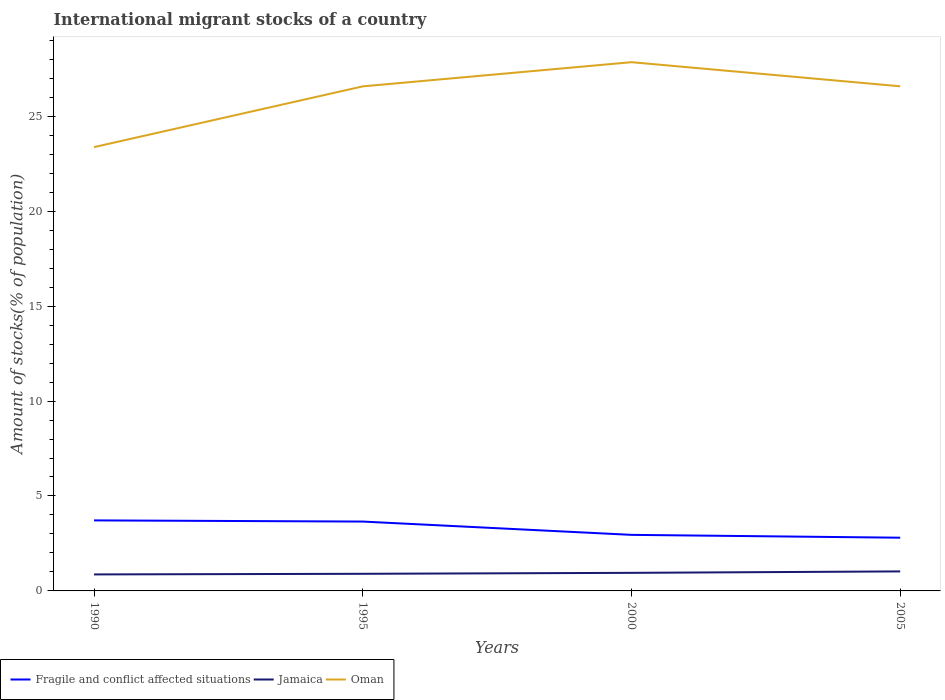How many different coloured lines are there?
Ensure brevity in your answer.  3. Is the number of lines equal to the number of legend labels?
Offer a very short reply. Yes. Across all years, what is the maximum amount of stocks in in Oman?
Provide a succinct answer. 23.37. What is the total amount of stocks in in Jamaica in the graph?
Give a very brief answer. -0.03. What is the difference between the highest and the second highest amount of stocks in in Oman?
Give a very brief answer. 4.47. What is the difference between the highest and the lowest amount of stocks in in Fragile and conflict affected situations?
Your answer should be compact. 2. How many years are there in the graph?
Your answer should be very brief. 4. What is the difference between two consecutive major ticks on the Y-axis?
Ensure brevity in your answer.  5. Are the values on the major ticks of Y-axis written in scientific E-notation?
Provide a succinct answer. No. Does the graph contain grids?
Your answer should be compact. No. Where does the legend appear in the graph?
Provide a short and direct response. Bottom left. How many legend labels are there?
Provide a succinct answer. 3. What is the title of the graph?
Offer a very short reply. International migrant stocks of a country. What is the label or title of the X-axis?
Your answer should be very brief. Years. What is the label or title of the Y-axis?
Give a very brief answer. Amount of stocks(% of population). What is the Amount of stocks(% of population) of Fragile and conflict affected situations in 1990?
Your answer should be very brief. 3.72. What is the Amount of stocks(% of population) of Jamaica in 1990?
Provide a succinct answer. 0.87. What is the Amount of stocks(% of population) of Oman in 1990?
Your answer should be compact. 23.37. What is the Amount of stocks(% of population) in Fragile and conflict affected situations in 1995?
Ensure brevity in your answer.  3.65. What is the Amount of stocks(% of population) in Jamaica in 1995?
Keep it short and to the point. 0.9. What is the Amount of stocks(% of population) of Oman in 1995?
Make the answer very short. 26.57. What is the Amount of stocks(% of population) in Fragile and conflict affected situations in 2000?
Keep it short and to the point. 2.95. What is the Amount of stocks(% of population) of Jamaica in 2000?
Your answer should be very brief. 0.95. What is the Amount of stocks(% of population) of Oman in 2000?
Keep it short and to the point. 27.85. What is the Amount of stocks(% of population) of Fragile and conflict affected situations in 2005?
Your answer should be compact. 2.8. What is the Amount of stocks(% of population) of Jamaica in 2005?
Provide a short and direct response. 1.03. What is the Amount of stocks(% of population) in Oman in 2005?
Your response must be concise. 26.58. Across all years, what is the maximum Amount of stocks(% of population) of Fragile and conflict affected situations?
Give a very brief answer. 3.72. Across all years, what is the maximum Amount of stocks(% of population) of Jamaica?
Make the answer very short. 1.03. Across all years, what is the maximum Amount of stocks(% of population) in Oman?
Your response must be concise. 27.85. Across all years, what is the minimum Amount of stocks(% of population) in Fragile and conflict affected situations?
Ensure brevity in your answer.  2.8. Across all years, what is the minimum Amount of stocks(% of population) of Jamaica?
Your response must be concise. 0.87. Across all years, what is the minimum Amount of stocks(% of population) of Oman?
Offer a very short reply. 23.37. What is the total Amount of stocks(% of population) of Fragile and conflict affected situations in the graph?
Keep it short and to the point. 13.12. What is the total Amount of stocks(% of population) in Jamaica in the graph?
Provide a short and direct response. 3.75. What is the total Amount of stocks(% of population) in Oman in the graph?
Your answer should be very brief. 104.37. What is the difference between the Amount of stocks(% of population) of Fragile and conflict affected situations in 1990 and that in 1995?
Offer a very short reply. 0.06. What is the difference between the Amount of stocks(% of population) in Jamaica in 1990 and that in 1995?
Keep it short and to the point. -0.03. What is the difference between the Amount of stocks(% of population) of Fragile and conflict affected situations in 1990 and that in 2000?
Your response must be concise. 0.76. What is the difference between the Amount of stocks(% of population) of Jamaica in 1990 and that in 2000?
Your answer should be compact. -0.08. What is the difference between the Amount of stocks(% of population) of Oman in 1990 and that in 2000?
Your answer should be very brief. -4.47. What is the difference between the Amount of stocks(% of population) of Fragile and conflict affected situations in 1990 and that in 2005?
Make the answer very short. 0.91. What is the difference between the Amount of stocks(% of population) of Jamaica in 1990 and that in 2005?
Offer a terse response. -0.16. What is the difference between the Amount of stocks(% of population) of Oman in 1990 and that in 2005?
Offer a very short reply. -3.2. What is the difference between the Amount of stocks(% of population) of Fragile and conflict affected situations in 1995 and that in 2000?
Keep it short and to the point. 0.7. What is the difference between the Amount of stocks(% of population) of Jamaica in 1995 and that in 2000?
Your answer should be very brief. -0.05. What is the difference between the Amount of stocks(% of population) in Oman in 1995 and that in 2000?
Your answer should be compact. -1.27. What is the difference between the Amount of stocks(% of population) in Fragile and conflict affected situations in 1995 and that in 2005?
Your answer should be compact. 0.85. What is the difference between the Amount of stocks(% of population) in Jamaica in 1995 and that in 2005?
Keep it short and to the point. -0.13. What is the difference between the Amount of stocks(% of population) in Oman in 1995 and that in 2005?
Provide a short and direct response. -0. What is the difference between the Amount of stocks(% of population) in Fragile and conflict affected situations in 2000 and that in 2005?
Provide a short and direct response. 0.15. What is the difference between the Amount of stocks(% of population) of Jamaica in 2000 and that in 2005?
Your response must be concise. -0.08. What is the difference between the Amount of stocks(% of population) of Oman in 2000 and that in 2005?
Offer a very short reply. 1.27. What is the difference between the Amount of stocks(% of population) in Fragile and conflict affected situations in 1990 and the Amount of stocks(% of population) in Jamaica in 1995?
Your answer should be compact. 2.81. What is the difference between the Amount of stocks(% of population) of Fragile and conflict affected situations in 1990 and the Amount of stocks(% of population) of Oman in 1995?
Keep it short and to the point. -22.86. What is the difference between the Amount of stocks(% of population) in Jamaica in 1990 and the Amount of stocks(% of population) in Oman in 1995?
Keep it short and to the point. -25.71. What is the difference between the Amount of stocks(% of population) of Fragile and conflict affected situations in 1990 and the Amount of stocks(% of population) of Jamaica in 2000?
Ensure brevity in your answer.  2.76. What is the difference between the Amount of stocks(% of population) of Fragile and conflict affected situations in 1990 and the Amount of stocks(% of population) of Oman in 2000?
Offer a terse response. -24.13. What is the difference between the Amount of stocks(% of population) of Jamaica in 1990 and the Amount of stocks(% of population) of Oman in 2000?
Ensure brevity in your answer.  -26.98. What is the difference between the Amount of stocks(% of population) of Fragile and conflict affected situations in 1990 and the Amount of stocks(% of population) of Jamaica in 2005?
Provide a succinct answer. 2.69. What is the difference between the Amount of stocks(% of population) in Fragile and conflict affected situations in 1990 and the Amount of stocks(% of population) in Oman in 2005?
Keep it short and to the point. -22.86. What is the difference between the Amount of stocks(% of population) in Jamaica in 1990 and the Amount of stocks(% of population) in Oman in 2005?
Provide a short and direct response. -25.71. What is the difference between the Amount of stocks(% of population) of Fragile and conflict affected situations in 1995 and the Amount of stocks(% of population) of Jamaica in 2000?
Your response must be concise. 2.7. What is the difference between the Amount of stocks(% of population) in Fragile and conflict affected situations in 1995 and the Amount of stocks(% of population) in Oman in 2000?
Make the answer very short. -24.19. What is the difference between the Amount of stocks(% of population) of Jamaica in 1995 and the Amount of stocks(% of population) of Oman in 2000?
Offer a terse response. -26.95. What is the difference between the Amount of stocks(% of population) of Fragile and conflict affected situations in 1995 and the Amount of stocks(% of population) of Jamaica in 2005?
Offer a very short reply. 2.62. What is the difference between the Amount of stocks(% of population) of Fragile and conflict affected situations in 1995 and the Amount of stocks(% of population) of Oman in 2005?
Your answer should be very brief. -22.92. What is the difference between the Amount of stocks(% of population) of Jamaica in 1995 and the Amount of stocks(% of population) of Oman in 2005?
Offer a terse response. -25.68. What is the difference between the Amount of stocks(% of population) of Fragile and conflict affected situations in 2000 and the Amount of stocks(% of population) of Jamaica in 2005?
Your answer should be compact. 1.92. What is the difference between the Amount of stocks(% of population) of Fragile and conflict affected situations in 2000 and the Amount of stocks(% of population) of Oman in 2005?
Provide a succinct answer. -23.62. What is the difference between the Amount of stocks(% of population) of Jamaica in 2000 and the Amount of stocks(% of population) of Oman in 2005?
Offer a very short reply. -25.63. What is the average Amount of stocks(% of population) of Fragile and conflict affected situations per year?
Ensure brevity in your answer.  3.28. What is the average Amount of stocks(% of population) of Jamaica per year?
Provide a short and direct response. 0.94. What is the average Amount of stocks(% of population) in Oman per year?
Ensure brevity in your answer.  26.09. In the year 1990, what is the difference between the Amount of stocks(% of population) in Fragile and conflict affected situations and Amount of stocks(% of population) in Jamaica?
Your answer should be very brief. 2.85. In the year 1990, what is the difference between the Amount of stocks(% of population) of Fragile and conflict affected situations and Amount of stocks(% of population) of Oman?
Offer a very short reply. -19.66. In the year 1990, what is the difference between the Amount of stocks(% of population) in Jamaica and Amount of stocks(% of population) in Oman?
Ensure brevity in your answer.  -22.51. In the year 1995, what is the difference between the Amount of stocks(% of population) in Fragile and conflict affected situations and Amount of stocks(% of population) in Jamaica?
Your answer should be compact. 2.75. In the year 1995, what is the difference between the Amount of stocks(% of population) in Fragile and conflict affected situations and Amount of stocks(% of population) in Oman?
Ensure brevity in your answer.  -22.92. In the year 1995, what is the difference between the Amount of stocks(% of population) of Jamaica and Amount of stocks(% of population) of Oman?
Offer a terse response. -25.67. In the year 2000, what is the difference between the Amount of stocks(% of population) of Fragile and conflict affected situations and Amount of stocks(% of population) of Jamaica?
Ensure brevity in your answer.  2. In the year 2000, what is the difference between the Amount of stocks(% of population) of Fragile and conflict affected situations and Amount of stocks(% of population) of Oman?
Provide a short and direct response. -24.89. In the year 2000, what is the difference between the Amount of stocks(% of population) in Jamaica and Amount of stocks(% of population) in Oman?
Make the answer very short. -26.89. In the year 2005, what is the difference between the Amount of stocks(% of population) in Fragile and conflict affected situations and Amount of stocks(% of population) in Jamaica?
Make the answer very short. 1.78. In the year 2005, what is the difference between the Amount of stocks(% of population) in Fragile and conflict affected situations and Amount of stocks(% of population) in Oman?
Offer a terse response. -23.77. In the year 2005, what is the difference between the Amount of stocks(% of population) in Jamaica and Amount of stocks(% of population) in Oman?
Provide a succinct answer. -25.55. What is the ratio of the Amount of stocks(% of population) in Fragile and conflict affected situations in 1990 to that in 1995?
Provide a short and direct response. 1.02. What is the ratio of the Amount of stocks(% of population) in Jamaica in 1990 to that in 1995?
Your response must be concise. 0.96. What is the ratio of the Amount of stocks(% of population) of Oman in 1990 to that in 1995?
Make the answer very short. 0.88. What is the ratio of the Amount of stocks(% of population) of Fragile and conflict affected situations in 1990 to that in 2000?
Make the answer very short. 1.26. What is the ratio of the Amount of stocks(% of population) in Jamaica in 1990 to that in 2000?
Keep it short and to the point. 0.91. What is the ratio of the Amount of stocks(% of population) of Oman in 1990 to that in 2000?
Keep it short and to the point. 0.84. What is the ratio of the Amount of stocks(% of population) in Fragile and conflict affected situations in 1990 to that in 2005?
Your response must be concise. 1.33. What is the ratio of the Amount of stocks(% of population) in Jamaica in 1990 to that in 2005?
Keep it short and to the point. 0.84. What is the ratio of the Amount of stocks(% of population) of Oman in 1990 to that in 2005?
Provide a short and direct response. 0.88. What is the ratio of the Amount of stocks(% of population) in Fragile and conflict affected situations in 1995 to that in 2000?
Give a very brief answer. 1.24. What is the ratio of the Amount of stocks(% of population) in Jamaica in 1995 to that in 2000?
Provide a short and direct response. 0.95. What is the ratio of the Amount of stocks(% of population) in Oman in 1995 to that in 2000?
Make the answer very short. 0.95. What is the ratio of the Amount of stocks(% of population) in Fragile and conflict affected situations in 1995 to that in 2005?
Ensure brevity in your answer.  1.3. What is the ratio of the Amount of stocks(% of population) of Jamaica in 1995 to that in 2005?
Your response must be concise. 0.88. What is the ratio of the Amount of stocks(% of population) in Fragile and conflict affected situations in 2000 to that in 2005?
Ensure brevity in your answer.  1.05. What is the ratio of the Amount of stocks(% of population) in Jamaica in 2000 to that in 2005?
Keep it short and to the point. 0.93. What is the ratio of the Amount of stocks(% of population) of Oman in 2000 to that in 2005?
Give a very brief answer. 1.05. What is the difference between the highest and the second highest Amount of stocks(% of population) of Fragile and conflict affected situations?
Make the answer very short. 0.06. What is the difference between the highest and the second highest Amount of stocks(% of population) in Jamaica?
Offer a terse response. 0.08. What is the difference between the highest and the second highest Amount of stocks(% of population) in Oman?
Provide a short and direct response. 1.27. What is the difference between the highest and the lowest Amount of stocks(% of population) of Fragile and conflict affected situations?
Ensure brevity in your answer.  0.91. What is the difference between the highest and the lowest Amount of stocks(% of population) in Jamaica?
Ensure brevity in your answer.  0.16. What is the difference between the highest and the lowest Amount of stocks(% of population) in Oman?
Make the answer very short. 4.47. 